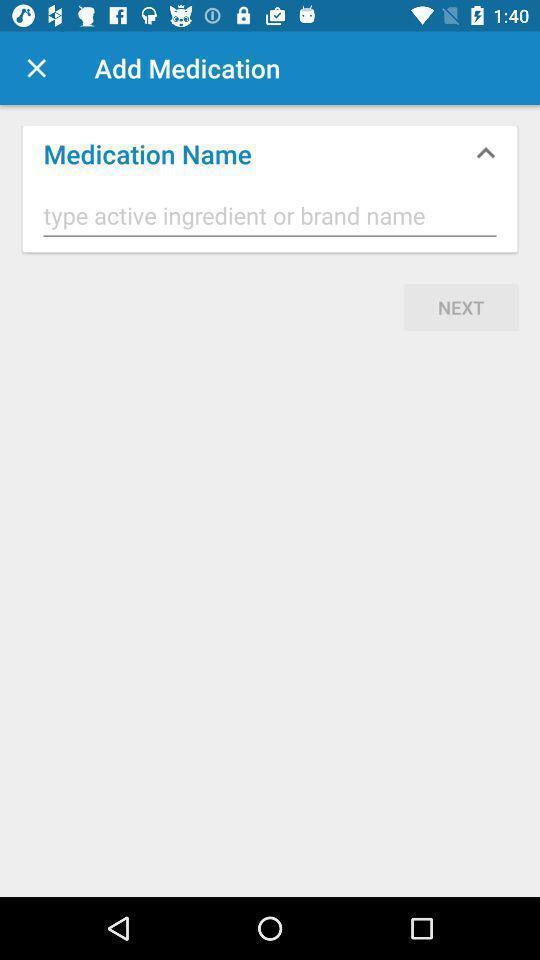Describe the key features of this screenshot. Page to enter details in a medical app. 